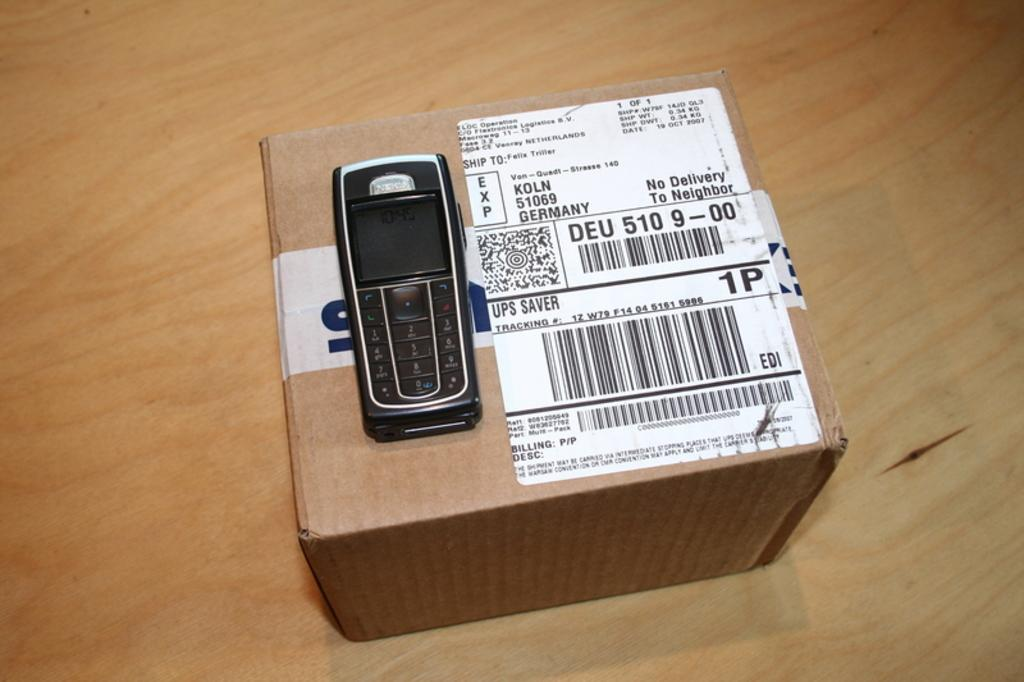<image>
Give a short and clear explanation of the subsequent image. A package label says "no delivery to neighbor" and has a cell phone on top of it. 